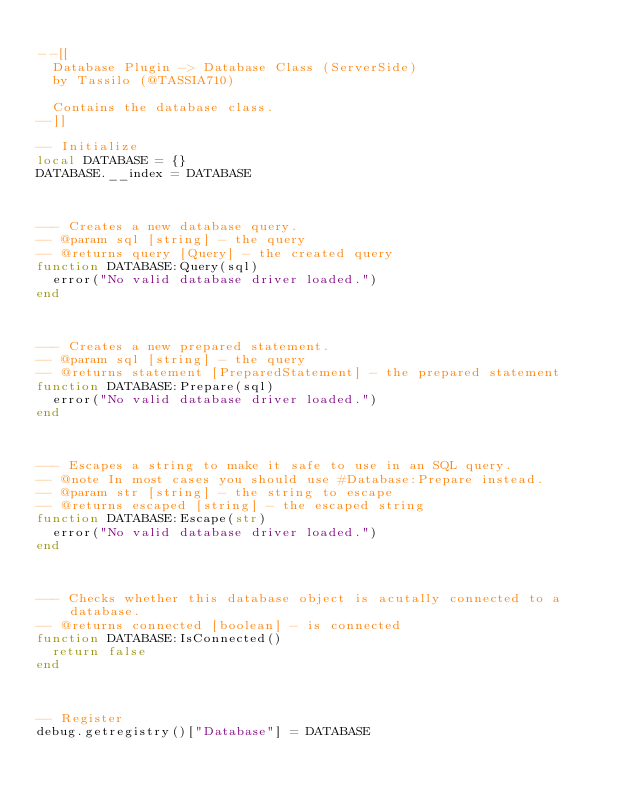Convert code to text. <code><loc_0><loc_0><loc_500><loc_500><_Lua_>
--[[
	Database Plugin -> Database Class (ServerSide)
	by Tassilo (@TASSIA710)

	Contains the database class.
--]]

-- Initialize
local DATABASE = {}
DATABASE.__index = DATABASE



--- Creates a new database query.
-- @param sql [string] - the query
-- @returns query [Query] - the created query
function DATABASE:Query(sql)
	error("No valid database driver loaded.")
end



--- Creates a new prepared statement.
-- @param sql [string] - the query
-- @returns statement [PreparedStatement] - the prepared statement
function DATABASE:Prepare(sql)
	error("No valid database driver loaded.")
end



--- Escapes a string to make it safe to use in an SQL query.
-- @note In most cases you should use #Database:Prepare instead.
-- @param str [string] - the string to escape
-- @returns escaped [string] - the escaped string
function DATABASE:Escape(str)
	error("No valid database driver loaded.")
end



--- Checks whether this database object is acutally connected to a database.
-- @returns connected [boolean] - is connected
function DATABASE:IsConnected()
	return false
end



-- Register
debug.getregistry()["Database"] = DATABASE
</code> 